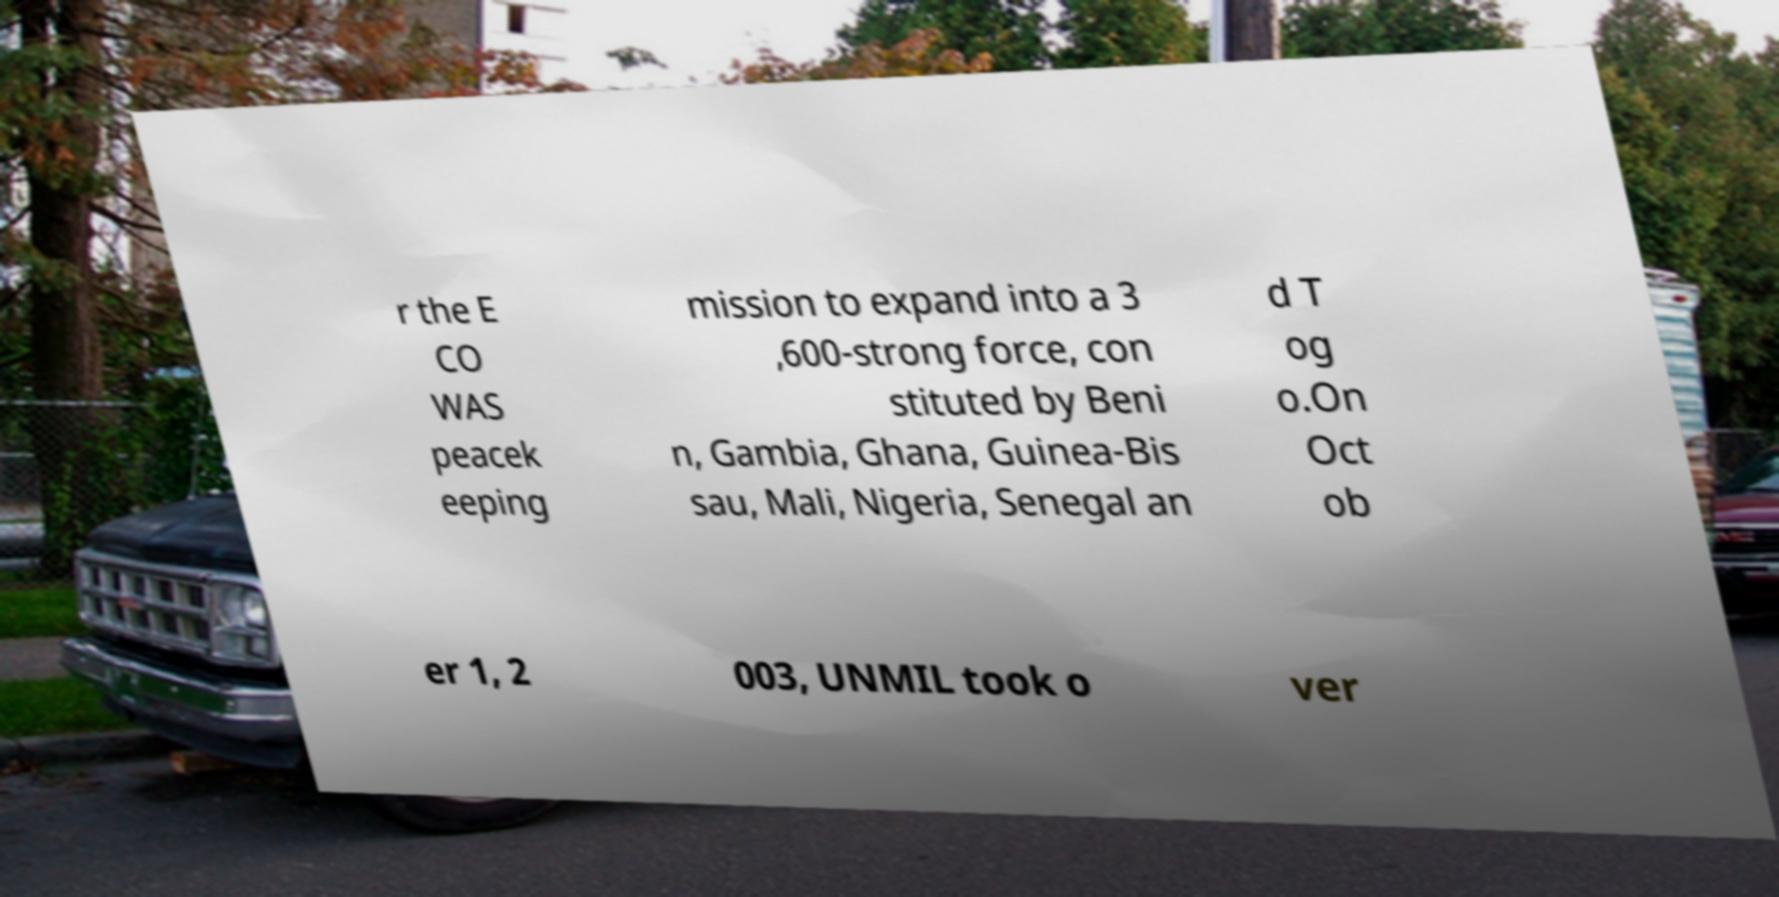Could you assist in decoding the text presented in this image and type it out clearly? r the E CO WAS peacek eeping mission to expand into a 3 ,600-strong force, con stituted by Beni n, Gambia, Ghana, Guinea-Bis sau, Mali, Nigeria, Senegal an d T og o.On Oct ob er 1, 2 003, UNMIL took o ver 